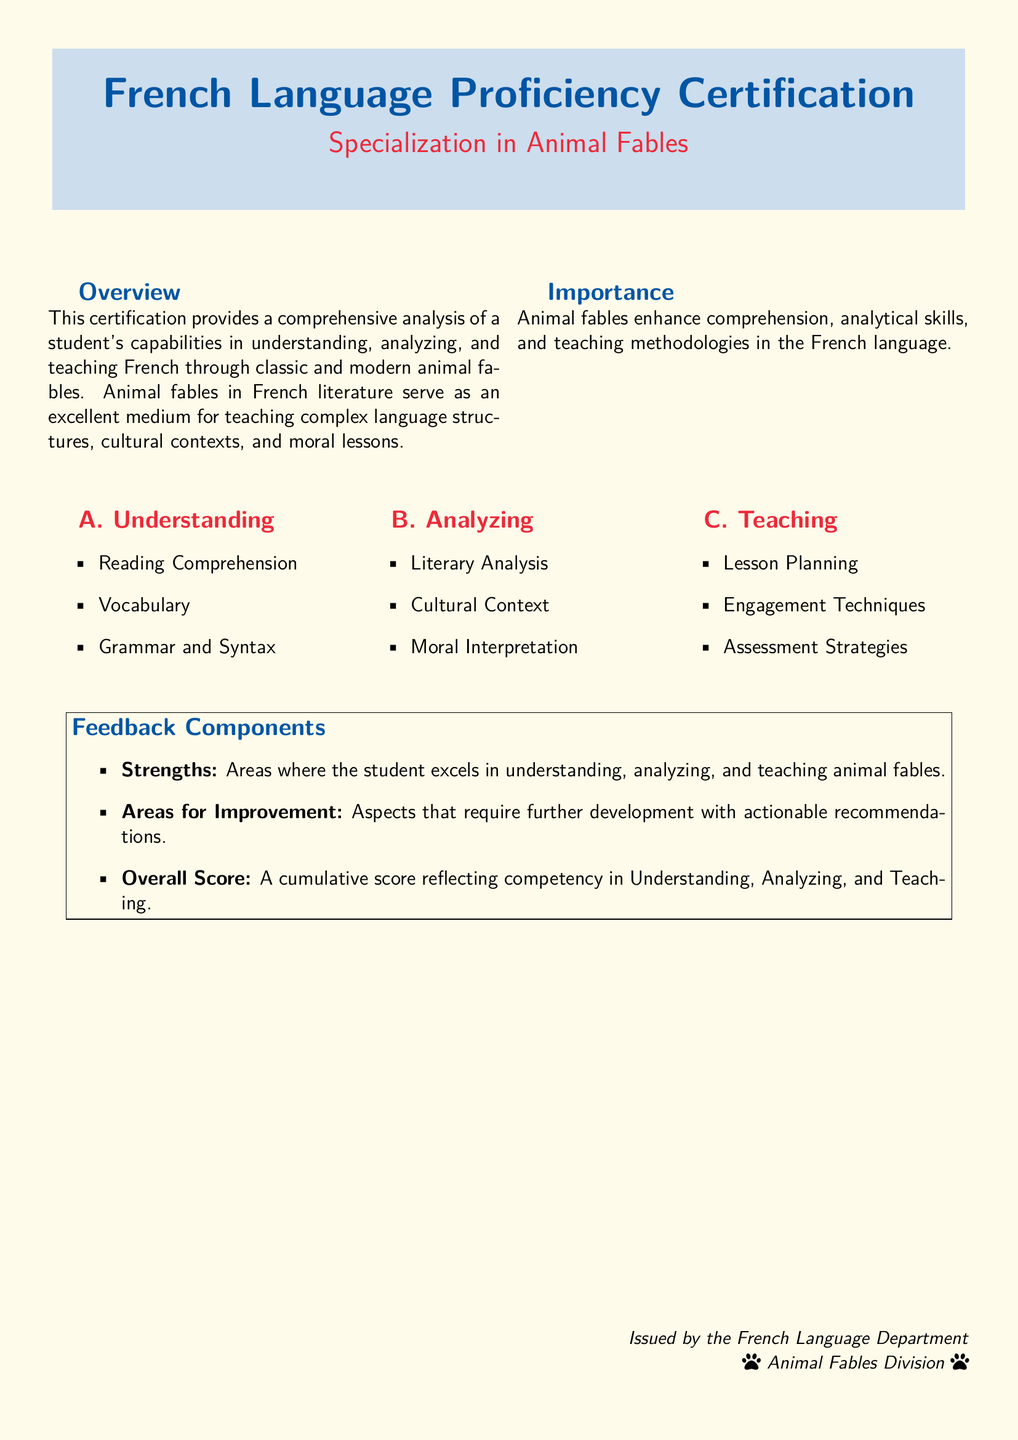What is the name of the certification? The certification is titled "French Language Proficiency Certification."
Answer: French Language Proficiency Certification What is the specialization of the certification? The document indicates a specialization in animal fables.
Answer: Specialization in Animal Fables What are the three main components of 'Understanding'? The components listed under Understanding are Reading Comprehension, Vocabulary, and Grammar and Syntax.
Answer: Reading Comprehension, Vocabulary, Grammar and Syntax Which division issues the certification? The document specifies that the certification is issued by the Animal Fables Division.
Answer: Animal Fables Division What is one of the feedback components mentioned? The feedback components include strengths, areas for improvement, and overall score.
Answer: Strengths How many columns are used to outline the main areas of focus? The document displays the main areas of focus in three distinct columns.
Answer: Three What do animal fables enhance according to the document? The document states that animal fables enhance comprehension, analytical skills, and teaching methodologies.
Answer: Comprehension, analytical skills, teaching methodologies What color is used for the background of the document? The document features a cream background color.
Answer: Cream What is the overall purpose of this certification? The purpose is to analyze a student's capabilities in understanding, analyzing, and teaching French through animal fables.
Answer: Comprehensive analysis of a student's capabilities 